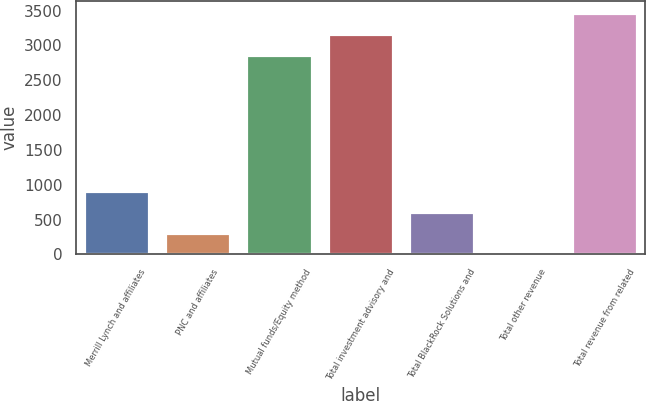<chart> <loc_0><loc_0><loc_500><loc_500><bar_chart><fcel>Merrill Lynch and affiliates<fcel>PNC and affiliates<fcel>Mutual funds/Equity method<fcel>Total investment advisory and<fcel>Total BlackRock Solutions and<fcel>Total other revenue<fcel>Total revenue from related<nl><fcel>906.7<fcel>306.9<fcel>2864<fcel>3163.9<fcel>606.8<fcel>7<fcel>3463.8<nl></chart> 